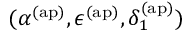<formula> <loc_0><loc_0><loc_500><loc_500>( \alpha ^ { ( a p ) } , \epsilon ^ { ( a p ) } , \delta _ { 1 } ^ { ( a p ) } )</formula> 